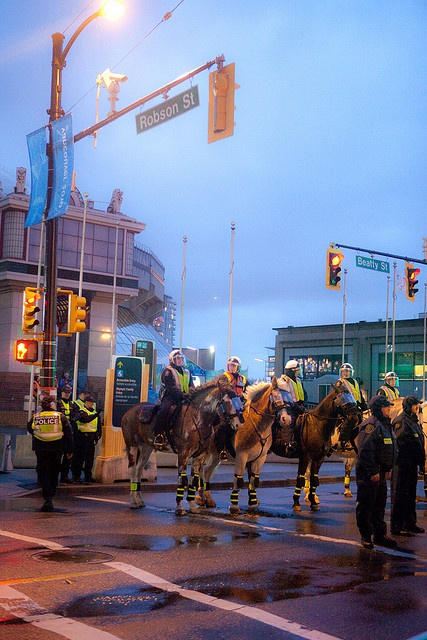Describe the objects in this image and their specific colors. I can see horse in lightblue, black, maroon, and gray tones, horse in lightblue, black, maroon, and brown tones, people in lightblue, black, maroon, and brown tones, horse in lightblue, black, maroon, and brown tones, and people in lightblue, black, maroon, and brown tones in this image. 